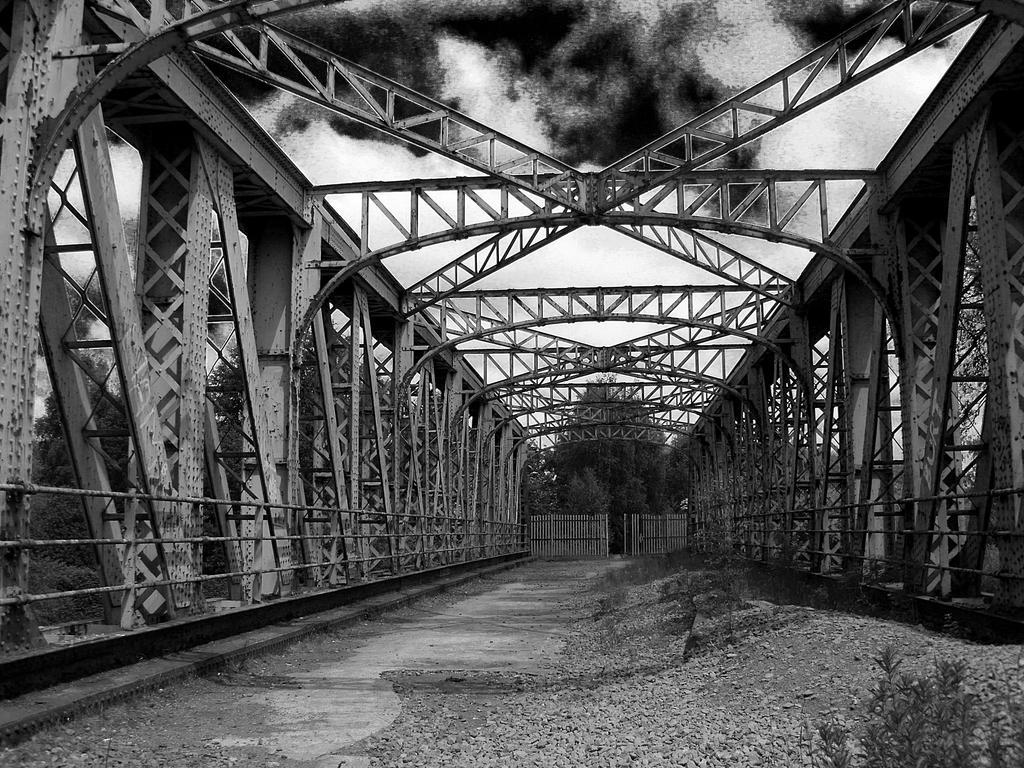Describe this image in one or two sentences. This black and white picture there are metal rods attached to the metal pillars which are having a fence before it. Middle of the image there is a fence. Bottom of the image there is a land. Background there are trees. Top of the image there is sky. Right bottom there are plants. 